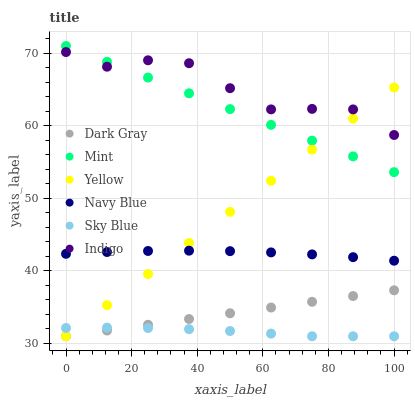Does Sky Blue have the minimum area under the curve?
Answer yes or no. Yes. Does Indigo have the maximum area under the curve?
Answer yes or no. Yes. Does Navy Blue have the minimum area under the curve?
Answer yes or no. No. Does Navy Blue have the maximum area under the curve?
Answer yes or no. No. Is Yellow the smoothest?
Answer yes or no. Yes. Is Indigo the roughest?
Answer yes or no. Yes. Is Navy Blue the smoothest?
Answer yes or no. No. Is Navy Blue the roughest?
Answer yes or no. No. Does Yellow have the lowest value?
Answer yes or no. Yes. Does Navy Blue have the lowest value?
Answer yes or no. No. Does Mint have the highest value?
Answer yes or no. Yes. Does Navy Blue have the highest value?
Answer yes or no. No. Is Navy Blue less than Indigo?
Answer yes or no. Yes. Is Mint greater than Navy Blue?
Answer yes or no. Yes. Does Sky Blue intersect Yellow?
Answer yes or no. Yes. Is Sky Blue less than Yellow?
Answer yes or no. No. Is Sky Blue greater than Yellow?
Answer yes or no. No. Does Navy Blue intersect Indigo?
Answer yes or no. No. 